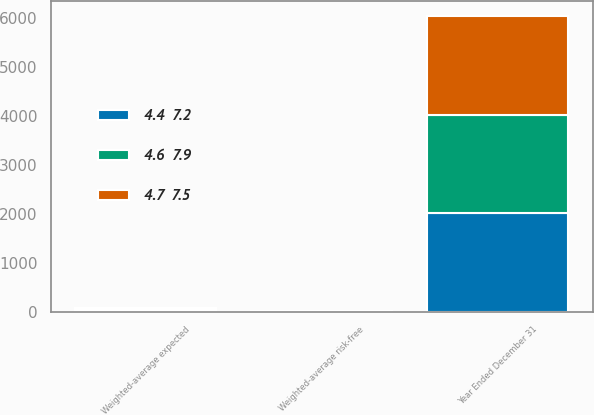<chart> <loc_0><loc_0><loc_500><loc_500><stacked_bar_chart><ecel><fcel>Year Ended December 31<fcel>Weighted-average expected<fcel>Weighted-average risk-free<nl><fcel>4.4  7.2<fcel>2015<fcel>28<fcel>2.2<nl><fcel>4.7  7.5<fcel>2014<fcel>28<fcel>2.4<nl><fcel>4.6  7.9<fcel>2013<fcel>28<fcel>2.5<nl></chart> 